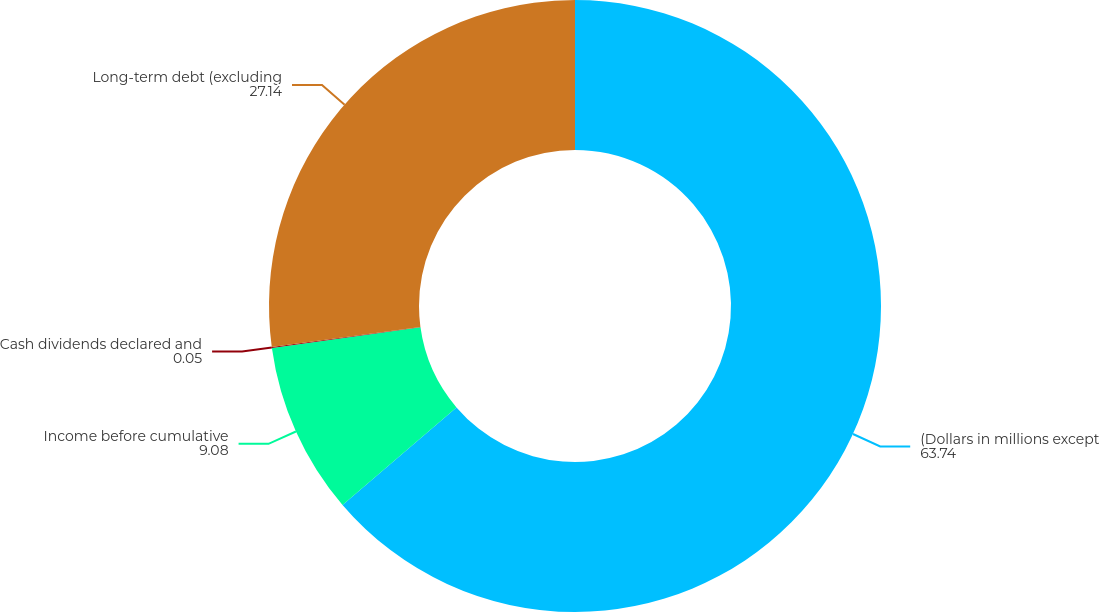<chart> <loc_0><loc_0><loc_500><loc_500><pie_chart><fcel>(Dollars in millions except<fcel>Income before cumulative<fcel>Cash dividends declared and<fcel>Long-term debt (excluding<nl><fcel>63.74%<fcel>9.08%<fcel>0.05%<fcel>27.14%<nl></chart> 